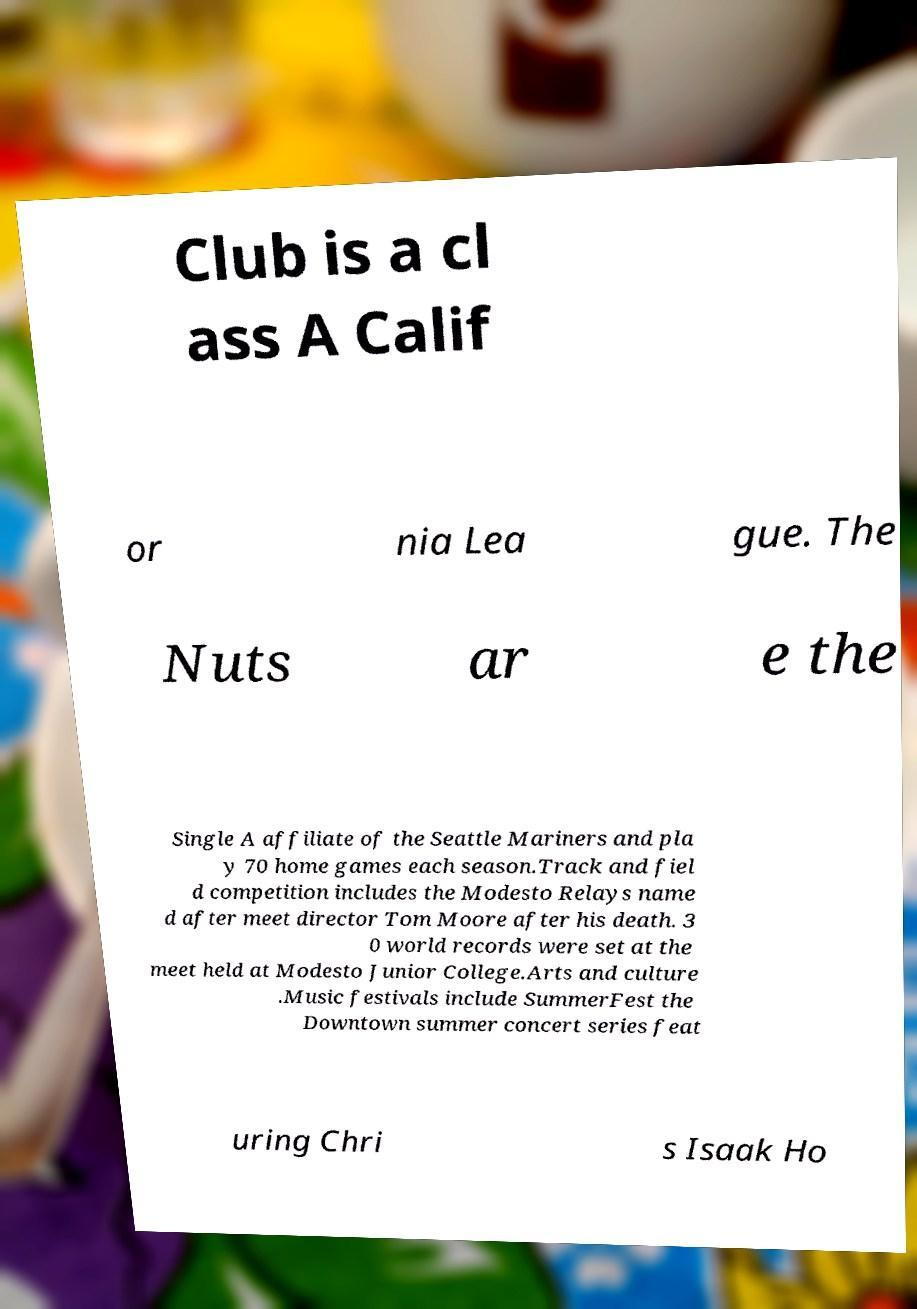Can you accurately transcribe the text from the provided image for me? Club is a cl ass A Calif or nia Lea gue. The Nuts ar e the Single A affiliate of the Seattle Mariners and pla y 70 home games each season.Track and fiel d competition includes the Modesto Relays name d after meet director Tom Moore after his death. 3 0 world records were set at the meet held at Modesto Junior College.Arts and culture .Music festivals include SummerFest the Downtown summer concert series feat uring Chri s Isaak Ho 